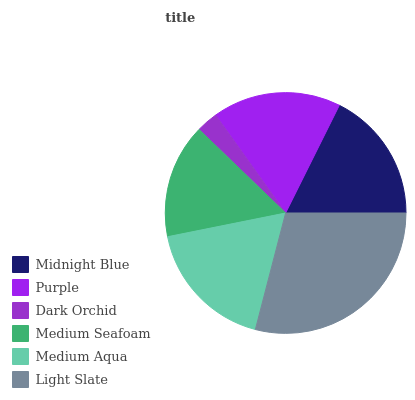Is Dark Orchid the minimum?
Answer yes or no. Yes. Is Light Slate the maximum?
Answer yes or no. Yes. Is Purple the minimum?
Answer yes or no. No. Is Purple the maximum?
Answer yes or no. No. Is Midnight Blue greater than Purple?
Answer yes or no. Yes. Is Purple less than Midnight Blue?
Answer yes or no. Yes. Is Purple greater than Midnight Blue?
Answer yes or no. No. Is Midnight Blue less than Purple?
Answer yes or no. No. Is Midnight Blue the high median?
Answer yes or no. Yes. Is Purple the low median?
Answer yes or no. Yes. Is Light Slate the high median?
Answer yes or no. No. Is Midnight Blue the low median?
Answer yes or no. No. 